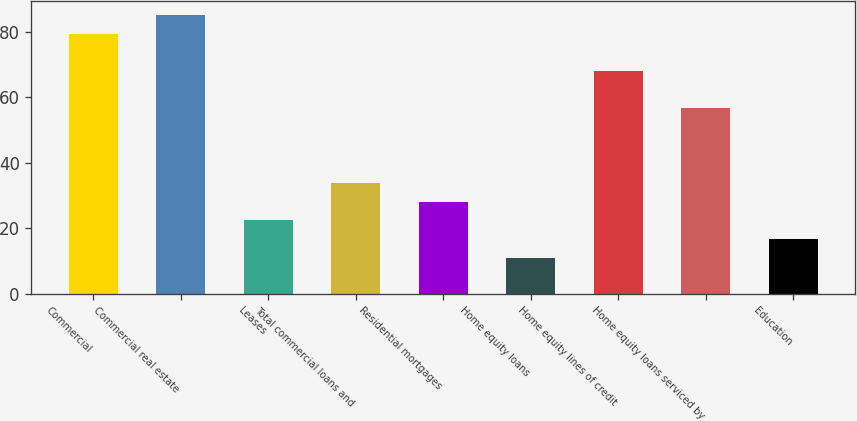<chart> <loc_0><loc_0><loc_500><loc_500><bar_chart><fcel>Commercial<fcel>Commercial real estate<fcel>Leases<fcel>Total commercial loans and<fcel>Residential mortgages<fcel>Home equity loans<fcel>Home equity lines of credit<fcel>Home equity loans serviced by<fcel>Education<nl><fcel>79.4<fcel>85.1<fcel>22.4<fcel>33.8<fcel>28.1<fcel>11<fcel>68<fcel>56.6<fcel>16.7<nl></chart> 